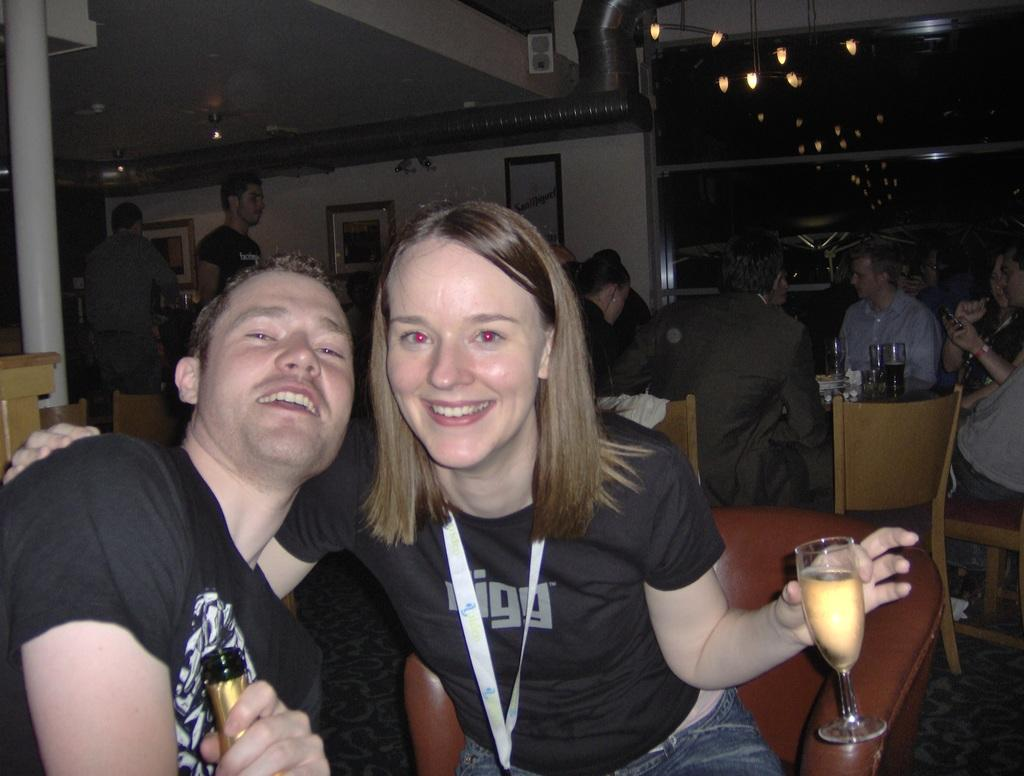Provide a one-sentence caption for the provided image. A man and woman with a Digg shirt pose for a photo at a busy bar. 